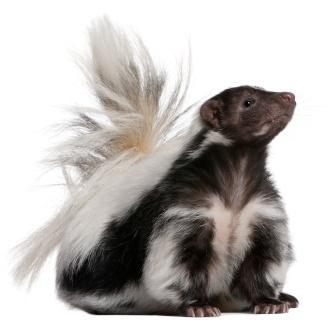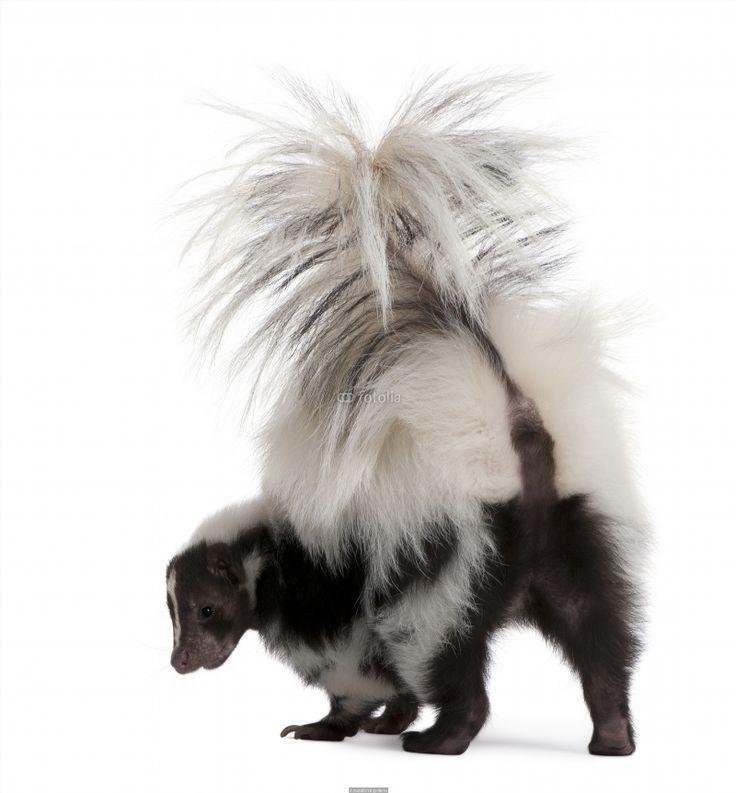The first image is the image on the left, the second image is the image on the right. Assess this claim about the two images: "The left and right image contains the same number of live skunks with at least one sitting on a white floor.". Correct or not? Answer yes or no. Yes. 